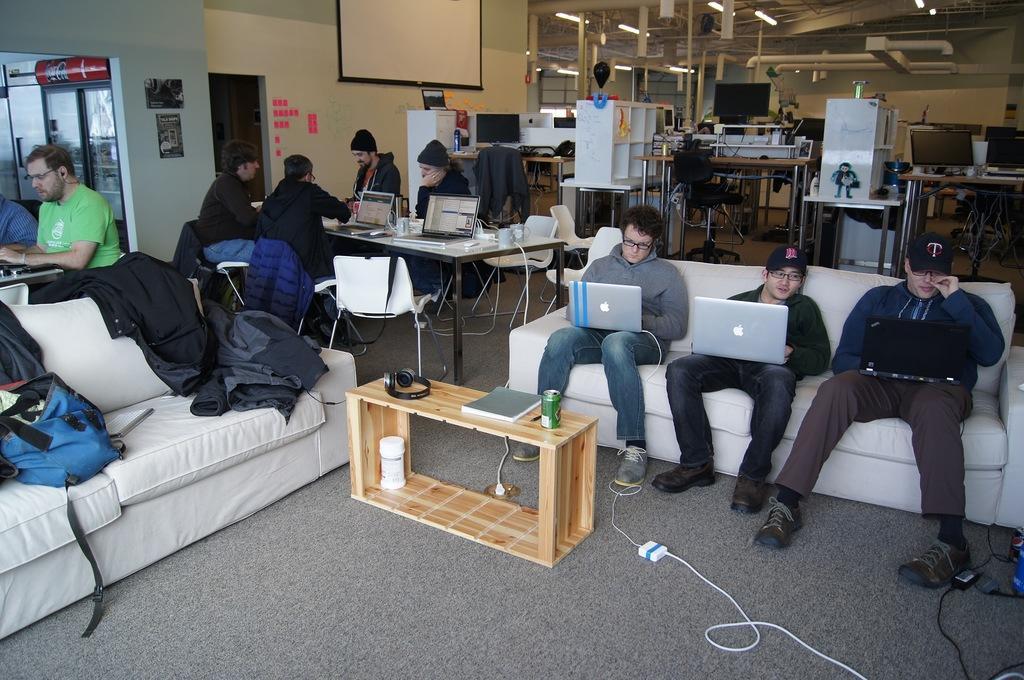How would you summarize this image in a sentence or two? In the image we can see there are lot of people who are sitting on sofa, chair and there are laptop in front of them on the table and there are laptops on their lap. 